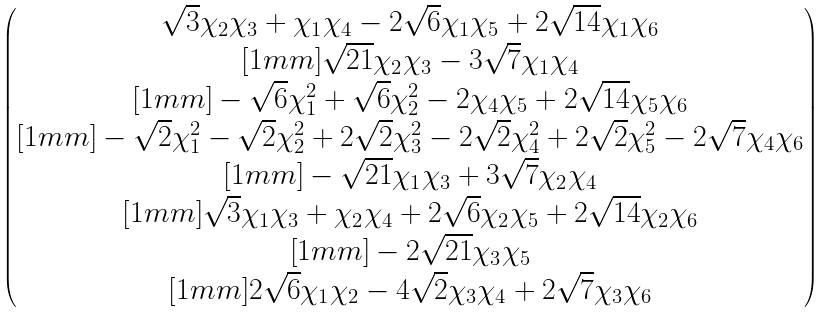<formula> <loc_0><loc_0><loc_500><loc_500>\begin{pmatrix} \sqrt { 3 } \chi _ { 2 } \chi _ { 3 } + \chi _ { 1 } \chi _ { 4 } - 2 \sqrt { 6 } \chi _ { 1 } \chi _ { 5 } + 2 \sqrt { 1 4 } \chi _ { 1 } \chi _ { 6 } \\ [ 1 m m ] \sqrt { 2 1 } \chi _ { 2 } \chi _ { 3 } - 3 \sqrt { 7 } \chi _ { 1 } \chi _ { 4 } \\ [ 1 m m ] - \sqrt { 6 } \chi _ { 1 } ^ { 2 } + \sqrt { 6 } \chi _ { 2 } ^ { 2 } - 2 \chi _ { 4 } \chi _ { 5 } + 2 \sqrt { 1 4 } \chi _ { 5 } \chi _ { 6 } \\ [ 1 m m ] - \sqrt { 2 } \chi _ { 1 } ^ { 2 } - \sqrt { 2 } \chi _ { 2 } ^ { 2 } + 2 \sqrt { 2 } \chi _ { 3 } ^ { 2 } - 2 \sqrt { 2 } \chi _ { 4 } ^ { 2 } + 2 \sqrt { 2 } \chi _ { 5 } ^ { 2 } - 2 \sqrt { 7 } \chi _ { 4 } \chi _ { 6 } \\ [ 1 m m ] - \sqrt { 2 1 } \chi _ { 1 } \chi _ { 3 } + 3 \sqrt { 7 } \chi _ { 2 } \chi _ { 4 } \\ [ 1 m m ] \sqrt { 3 } \chi _ { 1 } \chi _ { 3 } + \chi _ { 2 } \chi _ { 4 } + 2 \sqrt { 6 } \chi _ { 2 } \chi _ { 5 } + 2 \sqrt { 1 4 } \chi _ { 2 } \chi _ { 6 } \\ [ 1 m m ] - 2 \sqrt { 2 1 } \chi _ { 3 } \chi _ { 5 } \\ [ 1 m m ] 2 \sqrt { 6 } \chi _ { 1 } \chi _ { 2 } - 4 \sqrt { 2 } \chi _ { 3 } \chi _ { 4 } + 2 \sqrt { 7 } \chi _ { 3 } \chi _ { 6 } \end{pmatrix}</formula> 